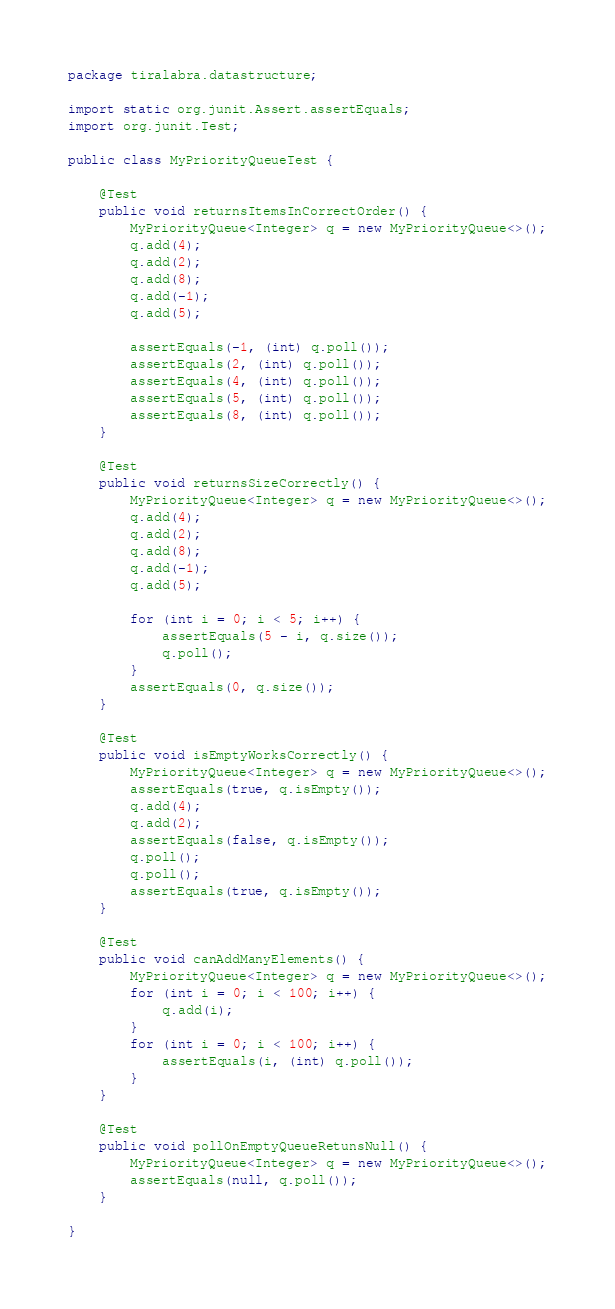<code> <loc_0><loc_0><loc_500><loc_500><_Java_>package tiralabra.datastructure;

import static org.junit.Assert.assertEquals;
import org.junit.Test;

public class MyPriorityQueueTest {

    @Test
    public void returnsItemsInCorrectOrder() {
        MyPriorityQueue<Integer> q = new MyPriorityQueue<>();
        q.add(4);
        q.add(2);
        q.add(8);
        q.add(-1);
        q.add(5);

        assertEquals(-1, (int) q.poll());
        assertEquals(2, (int) q.poll());
        assertEquals(4, (int) q.poll());
        assertEquals(5, (int) q.poll());
        assertEquals(8, (int) q.poll());
    }

    @Test
    public void returnsSizeCorrectly() {
        MyPriorityQueue<Integer> q = new MyPriorityQueue<>();
        q.add(4);
        q.add(2);
        q.add(8);
        q.add(-1);
        q.add(5);

        for (int i = 0; i < 5; i++) {
            assertEquals(5 - i, q.size());
            q.poll();
        }
        assertEquals(0, q.size());
    }

    @Test
    public void isEmptyWorksCorrectly() {
        MyPriorityQueue<Integer> q = new MyPriorityQueue<>();
        assertEquals(true, q.isEmpty());
        q.add(4);
        q.add(2);
        assertEquals(false, q.isEmpty());
        q.poll();
        q.poll();
        assertEquals(true, q.isEmpty());
    }

    @Test
    public void canAddManyElements() {
        MyPriorityQueue<Integer> q = new MyPriorityQueue<>();
        for (int i = 0; i < 100; i++) {
            q.add(i);
        }
        for (int i = 0; i < 100; i++) {
            assertEquals(i, (int) q.poll());
        }
    }

    @Test
    public void pollOnEmptyQueueRetunsNull() {
        MyPriorityQueue<Integer> q = new MyPriorityQueue<>();
        assertEquals(null, q.poll());
    }

}
</code> 